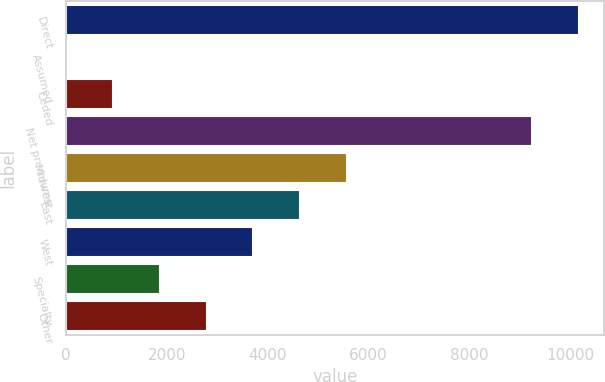Convert chart. <chart><loc_0><loc_0><loc_500><loc_500><bar_chart><fcel>Direct<fcel>Assumed<fcel>Ceded<fcel>Net premiums<fcel>Midwest<fcel>East<fcel>West<fcel>Specialty<fcel>Other<nl><fcel>10173.2<fcel>1.7<fcel>930.12<fcel>9244.8<fcel>5572.22<fcel>4643.8<fcel>3715.38<fcel>1858.54<fcel>2786.96<nl></chart> 